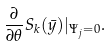Convert formula to latex. <formula><loc_0><loc_0><loc_500><loc_500>\frac { \partial } { \partial \theta } S _ { k } ( \bar { y } ) | _ { \Psi _ { j } = 0 } .</formula> 